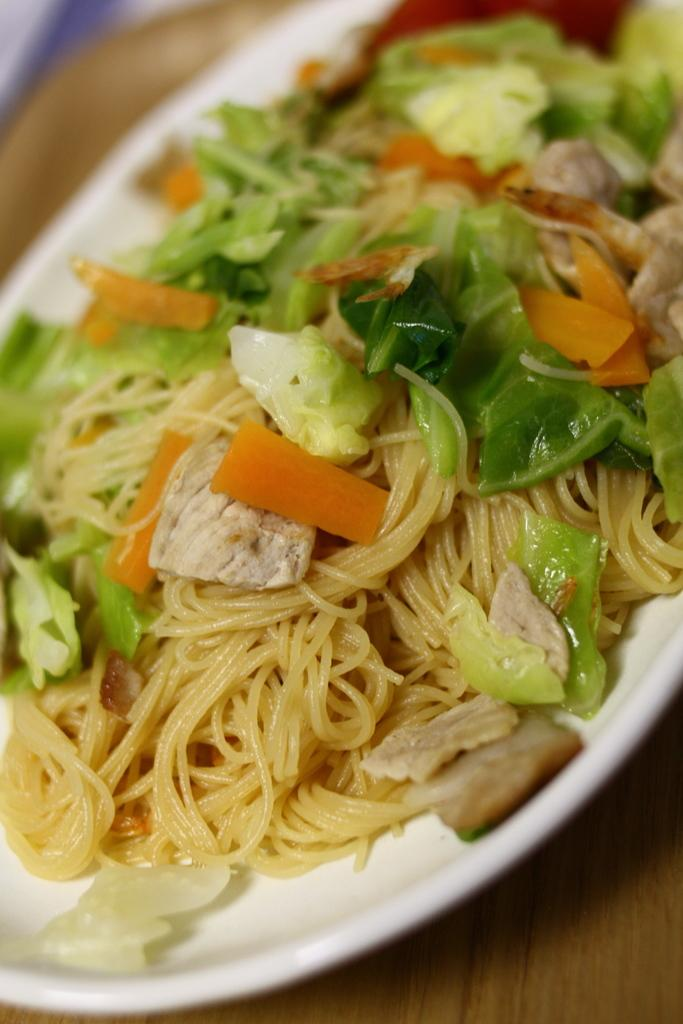What is the main subject of the image? The image contains a food item. How is the food item presented in the image? The food item is on a white plate. What is the surface beneath the plate made of? The plate is placed on a wooden surface. Reasoning: Let' Let's think step by step in order to produce the conversation. We start by identifying the main subject of the image, which is the food item. Then, we describe how the food item is presented, noting that it is on a white plate. Finally, we mention the surface beneath the plate, which is made of wood. Each question is designed to elicit a specific detail about the image that is known from the provided facts. Absurd Question/Answer: What type of prison can be seen in the image? There is no prison present in the image; it features a food item on a white plate placed on a wooden surface. How does the wealth of the person who owns the food item in the image compare to others? The image does not provide any information about the wealth of the person who owns the food item or any comparison to others. What type of beetle can be seen crawling on the food item in the image? There is no beetle present in the image; it features a food item on a white plate placed on a wooden surface. 